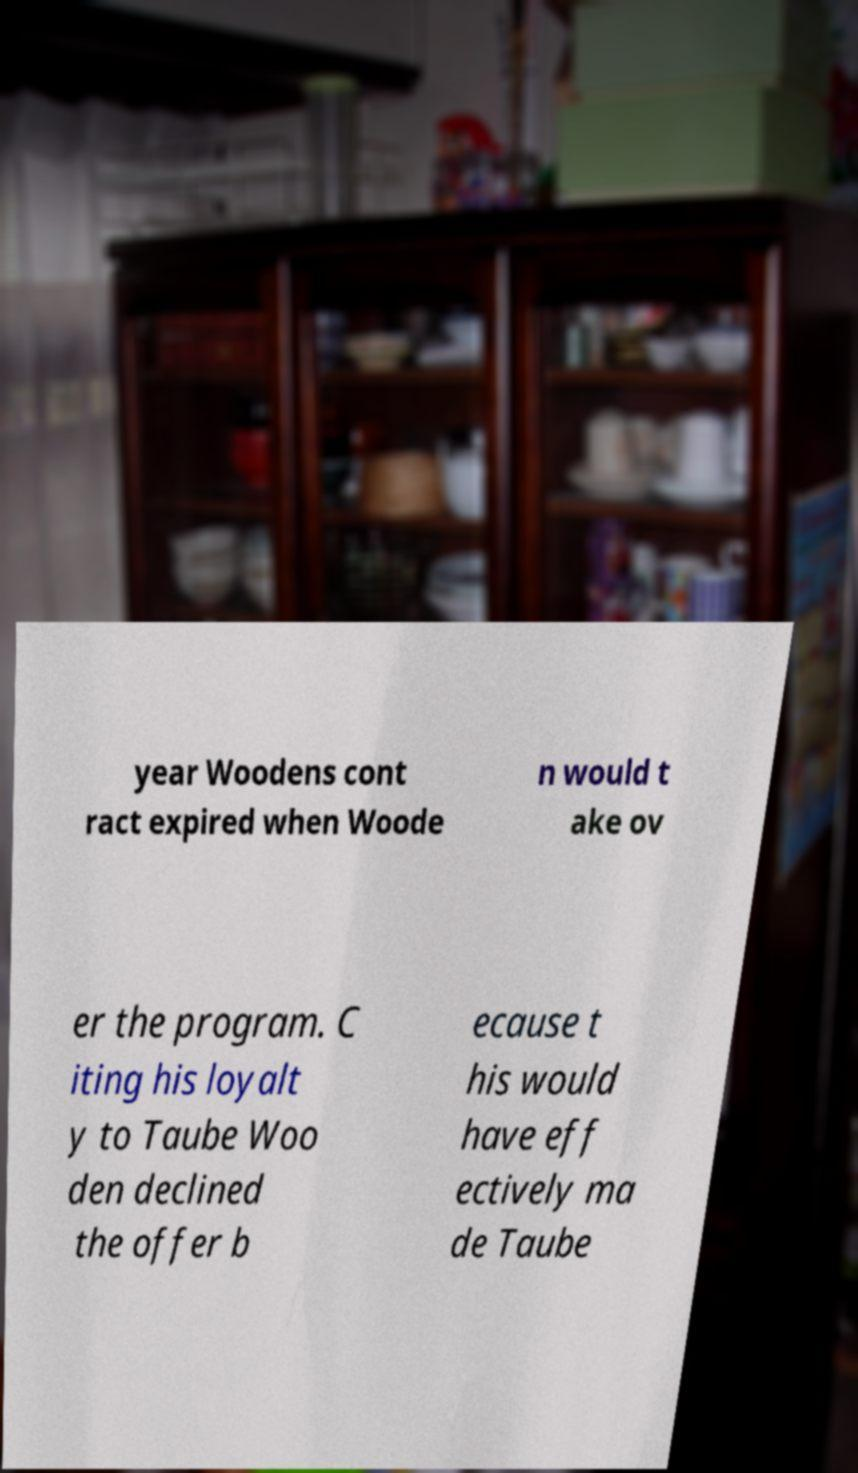Can you accurately transcribe the text from the provided image for me? year Woodens cont ract expired when Woode n would t ake ov er the program. C iting his loyalt y to Taube Woo den declined the offer b ecause t his would have eff ectively ma de Taube 